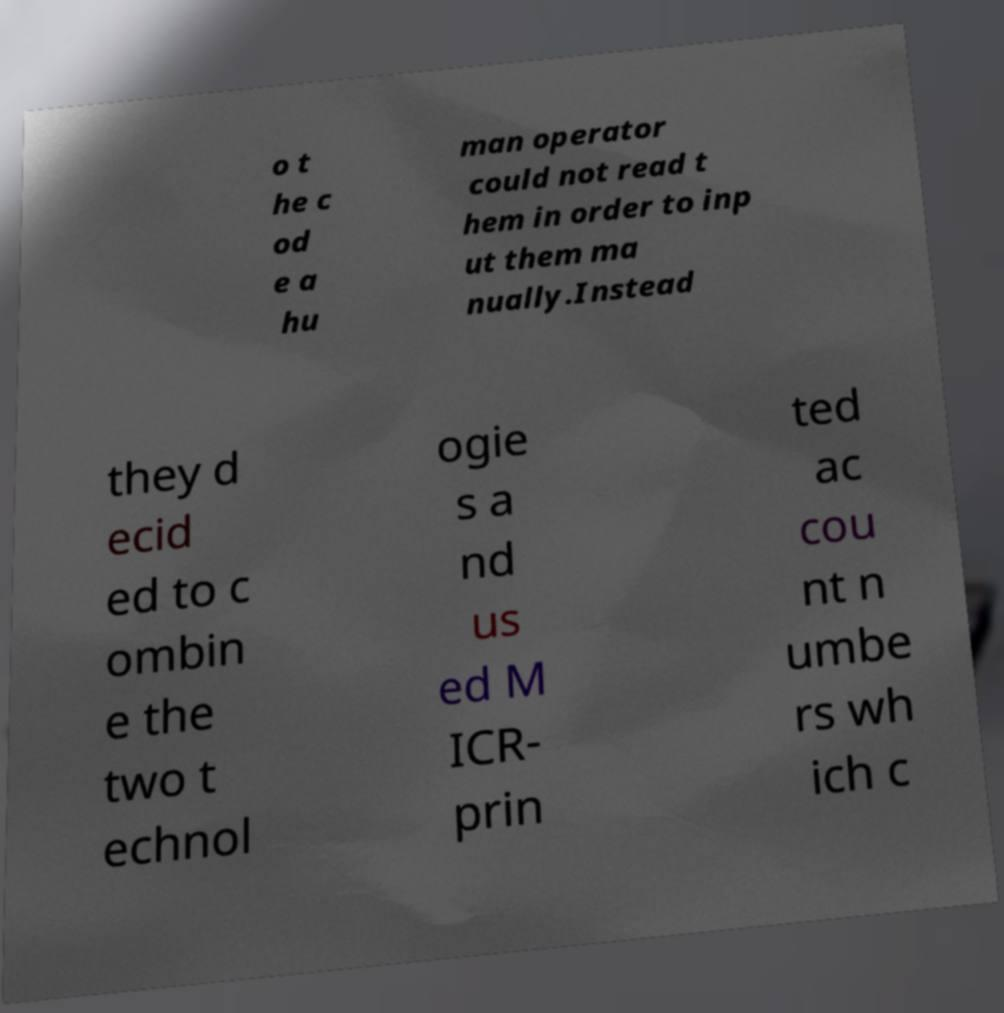Can you accurately transcribe the text from the provided image for me? o t he c od e a hu man operator could not read t hem in order to inp ut them ma nually.Instead they d ecid ed to c ombin e the two t echnol ogie s a nd us ed M ICR- prin ted ac cou nt n umbe rs wh ich c 